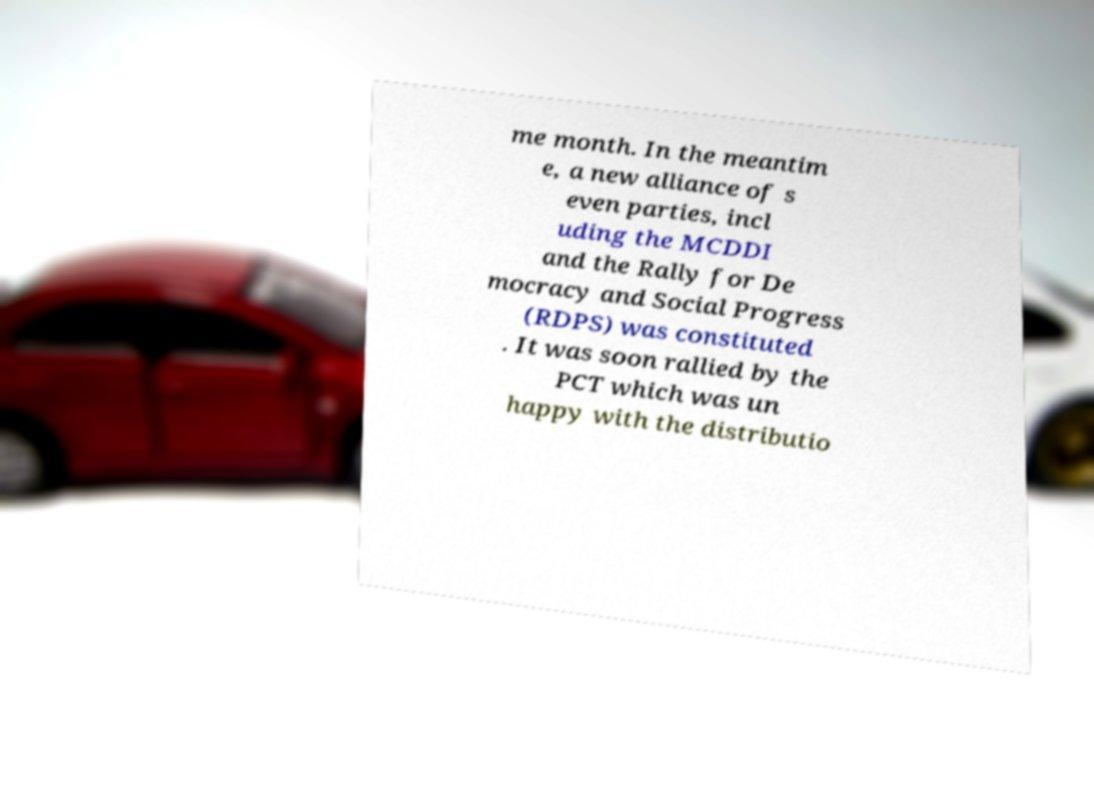Can you accurately transcribe the text from the provided image for me? me month. In the meantim e, a new alliance of s even parties, incl uding the MCDDI and the Rally for De mocracy and Social Progress (RDPS) was constituted . It was soon rallied by the PCT which was un happy with the distributio 